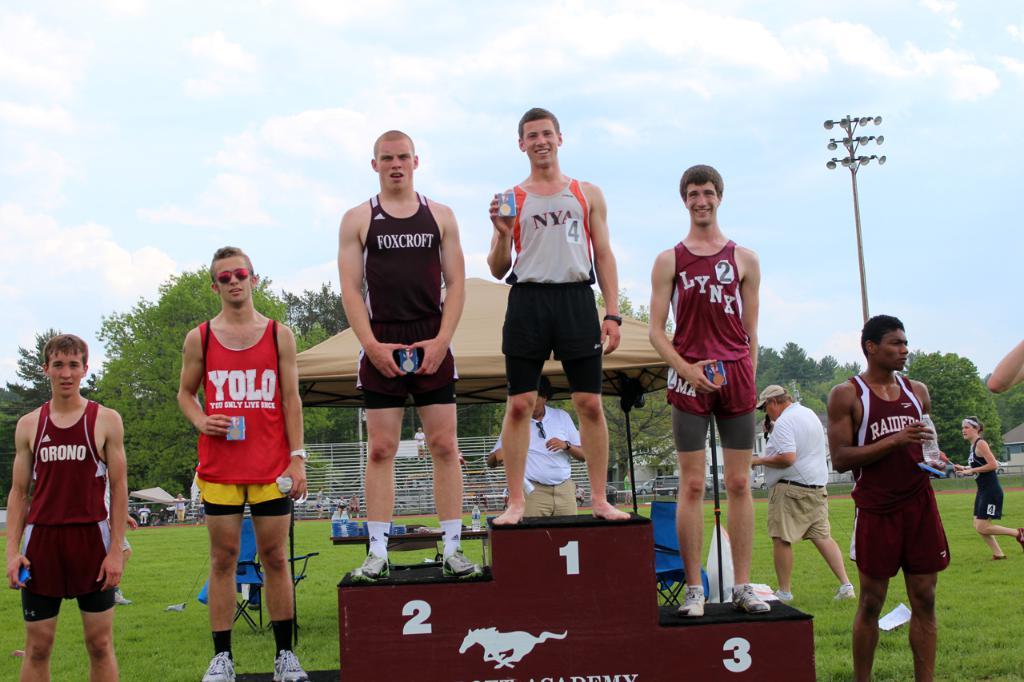What is the name on the second place person's shirt?
Offer a terse response. Foxcroft. 